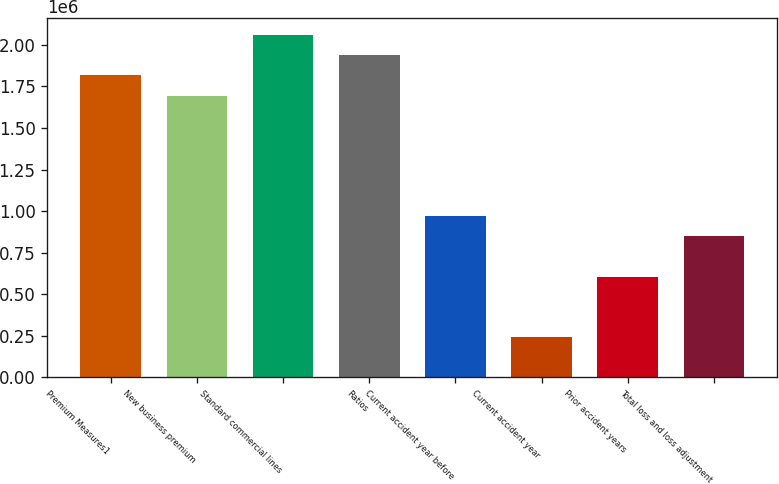Convert chart. <chart><loc_0><loc_0><loc_500><loc_500><bar_chart><fcel>Premium Measures1<fcel>New business premium<fcel>Standard commercial lines<fcel>Ratios<fcel>Current accident year before<fcel>Current accident year<fcel>Prior accident years<fcel>Total loss and loss adjustment<nl><fcel>1.81657e+06<fcel>1.69547e+06<fcel>2.05878e+06<fcel>1.93768e+06<fcel>968838<fcel>242209<fcel>605524<fcel>847733<nl></chart> 